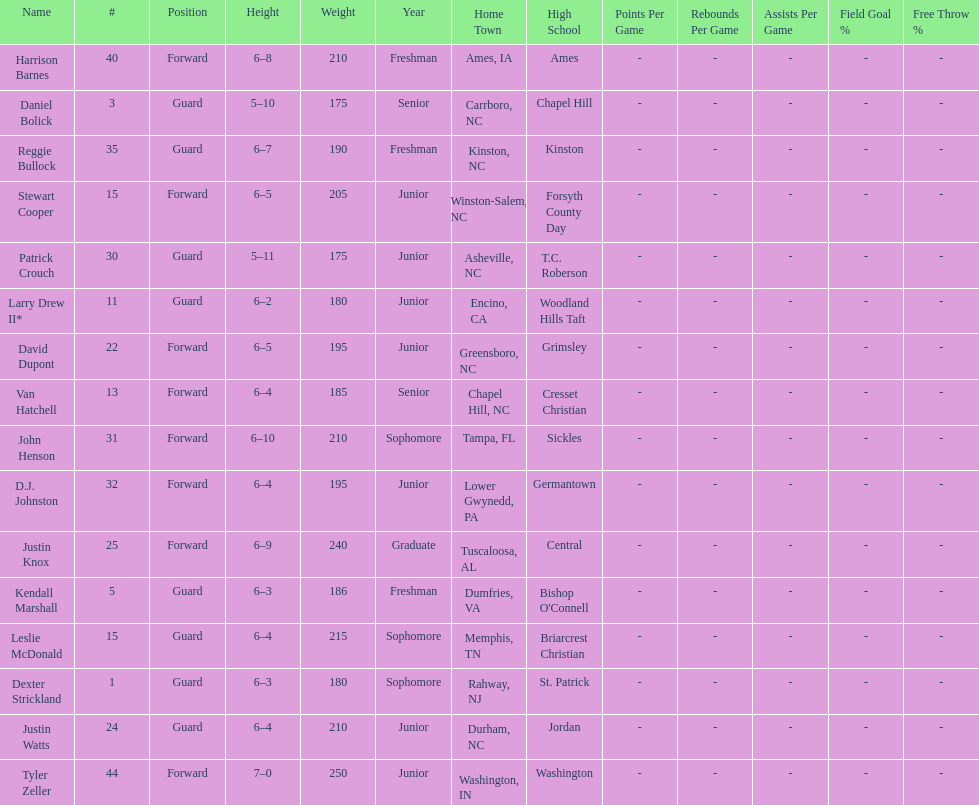Who had a greater height, justin knox or john henson? John Henson. 